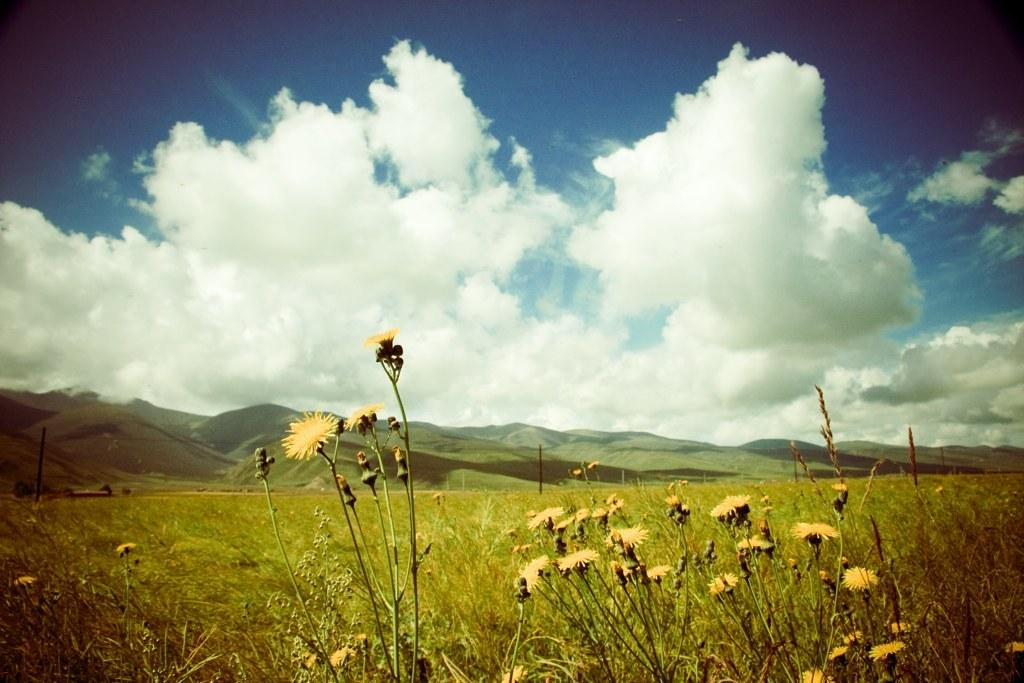What type of plants are at the bottom of the image? There are plants with flowers at the bottom of the image. What can be seen in the distance in the image? There are mountains in the background of the image. What is present in the sky in the image? There are clouds in the sky. What color is the sky in the image? The sky is blue in the image. How many beans are visible on the plants in the image? There are no beans present on the plants in the image; they have flowers instead. What type of stem can be seen supporting the recess in the image? There is no recess or stem present in the image; it features plants with flowers and mountains in the background. 